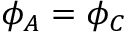<formula> <loc_0><loc_0><loc_500><loc_500>\phi _ { A } = \phi _ { C }</formula> 